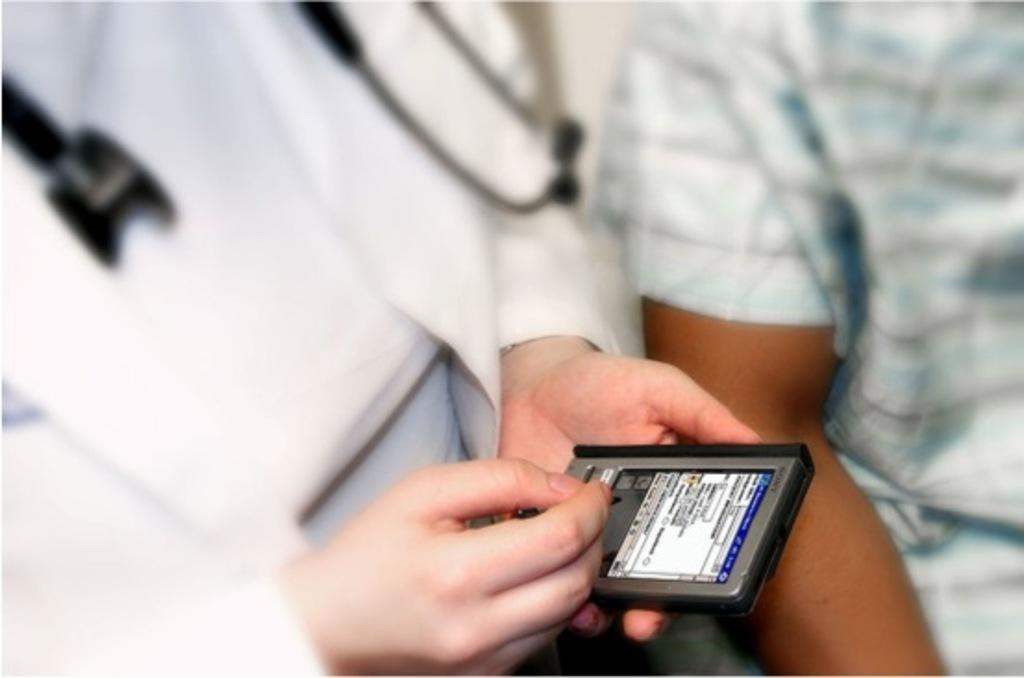How many people are in the image? There are two people in the image. What is one of the people doing in the image? One of the people is holding a gadget. What type of insurance policy is being discussed by the people in the image? There is no indication in the image that the people are discussing any type of insurance policy. 